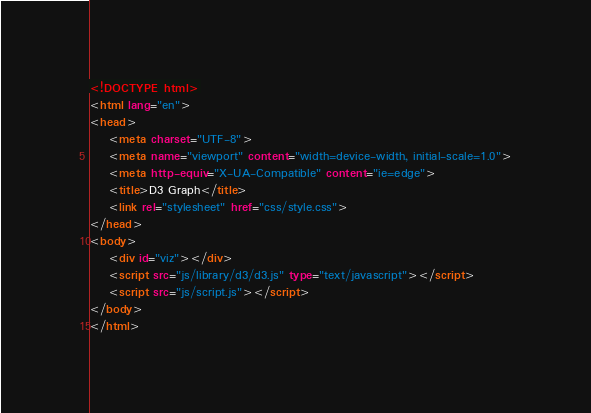<code> <loc_0><loc_0><loc_500><loc_500><_HTML_><!DOCTYPE html>
<html lang="en">
<head>
    <meta charset="UTF-8">
    <meta name="viewport" content="width=device-width, initial-scale=1.0">
    <meta http-equiv="X-UA-Compatible" content="ie=edge">
    <title>D3 Graph</title>
    <link rel="stylesheet" href="css/style.css">
</head>
<body>
    <div id="viz"></div>
    <script src="js/library/d3/d3.js" type="text/javascript"></script>
    <script src="js/script.js"></script>
</body>
</html></code> 